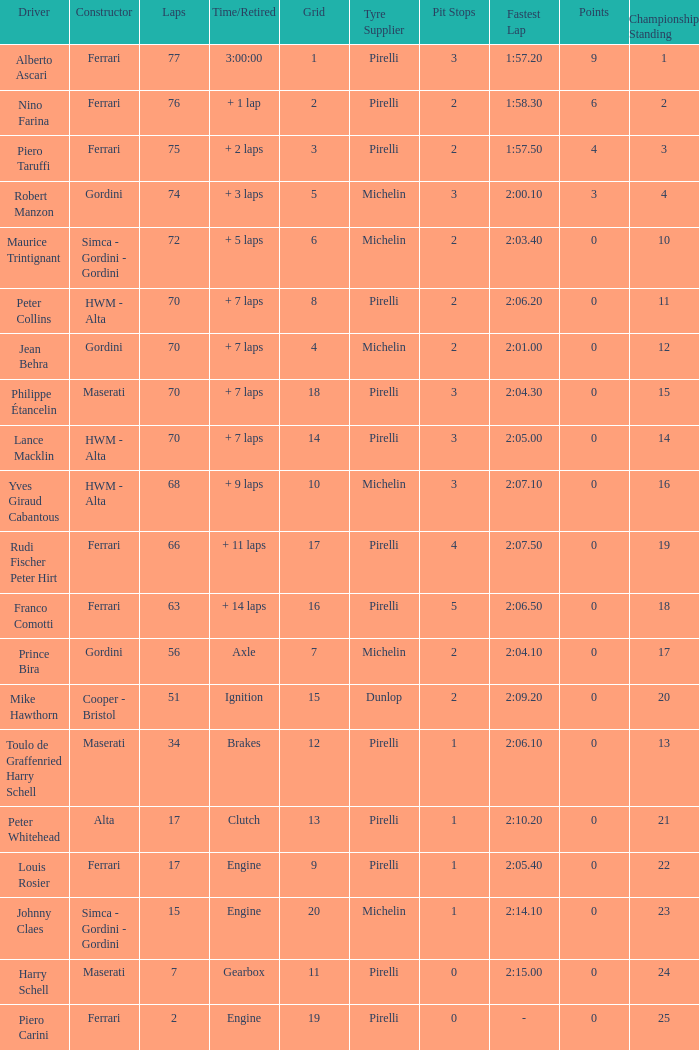How many grids for peter collins? 1.0. 